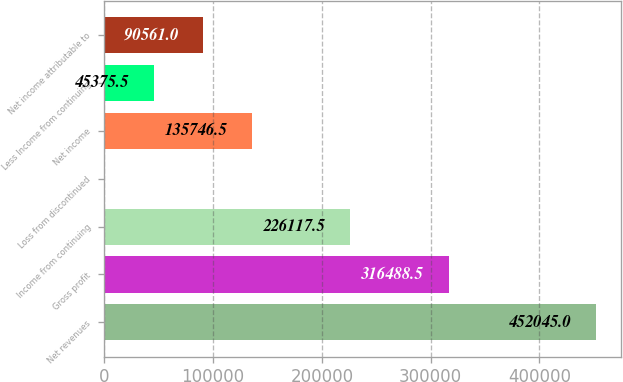<chart> <loc_0><loc_0><loc_500><loc_500><bar_chart><fcel>Net revenues<fcel>Gross profit<fcel>Income from continuing<fcel>Loss from discontinued<fcel>Net income<fcel>Less Income from continuing<fcel>Net income attributable to<nl><fcel>452045<fcel>316488<fcel>226118<fcel>190<fcel>135746<fcel>45375.5<fcel>90561<nl></chart> 